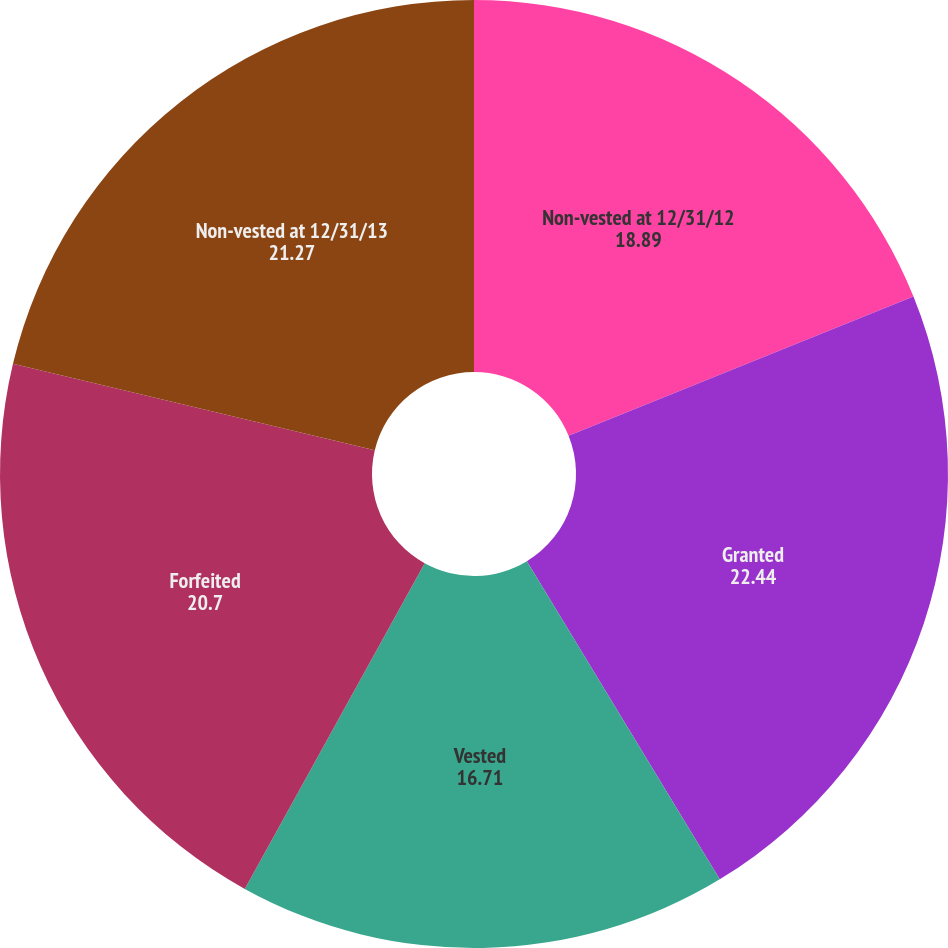Convert chart. <chart><loc_0><loc_0><loc_500><loc_500><pie_chart><fcel>Non-vested at 12/31/12<fcel>Granted<fcel>Vested<fcel>Forfeited<fcel>Non-vested at 12/31/13<nl><fcel>18.89%<fcel>22.44%<fcel>16.71%<fcel>20.7%<fcel>21.27%<nl></chart> 